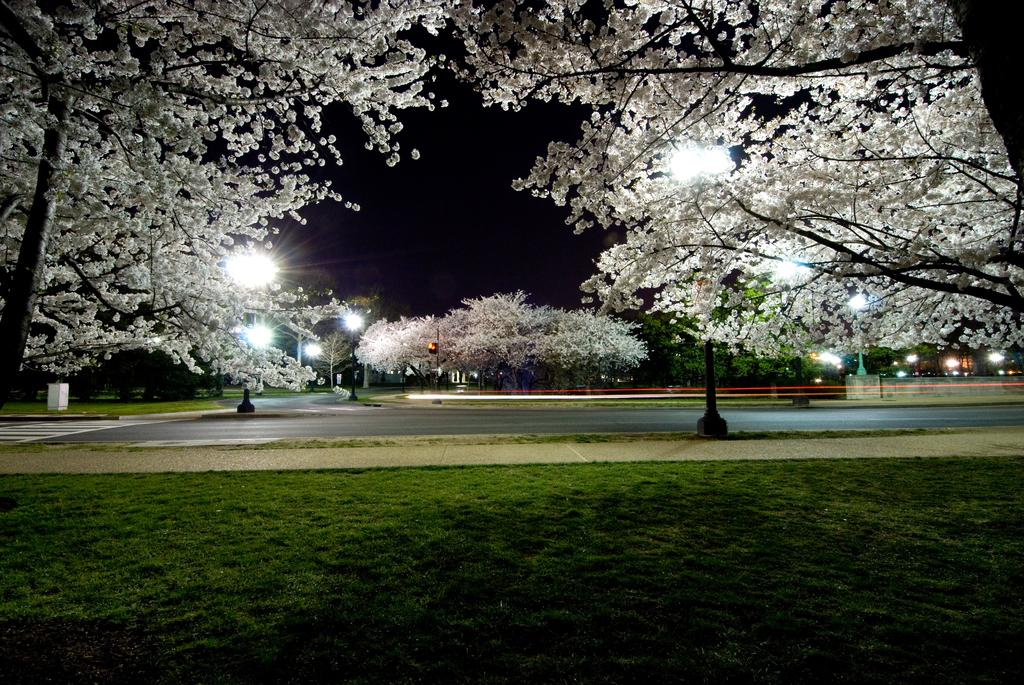What type of vegetation is present in the image? There are trees in the image. What is special about the trees in the image? The trees have blossoms. What is at the bottom of the image? There is grass at the bottom of the image. What can be seen in the background of the image? There are lights and poles in the background of the image. What part of the natural environment is visible in the image? The sky is visible in the image. What type of twig is the person holding in the image? There is no person holding a twig in the image; it only features trees, grass, lights, poles, and the sky. What holiday is being celebrated in the image? There is no indication of a holiday being celebrated in the image. 